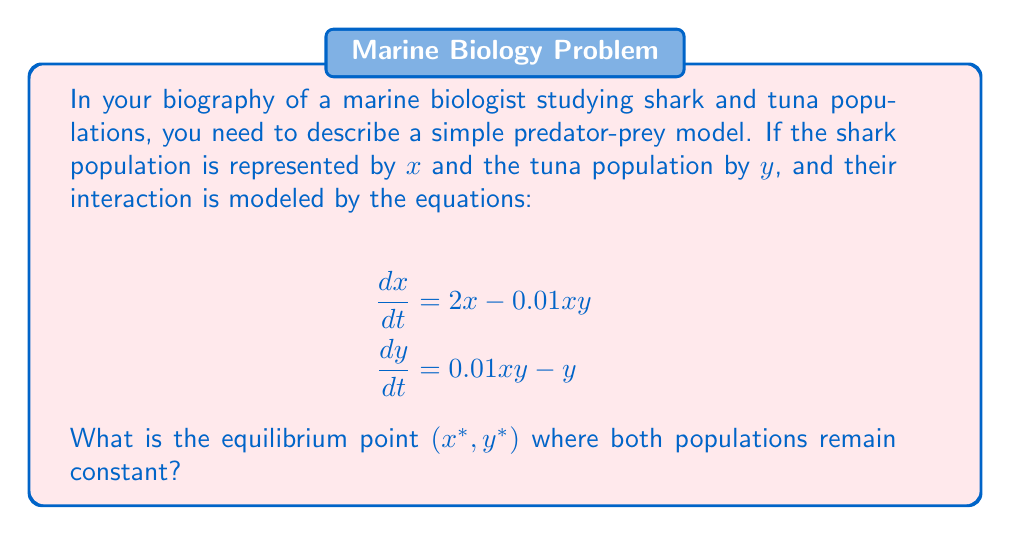Give your solution to this math problem. To find the equilibrium point, we need to set both equations equal to zero and solve for $x$ and $y$:

1. From the first equation:
   $$2x - 0.01xy = 0$$
   $$x(2 - 0.01y) = 0$$
   Either $x = 0$ or $2 - 0.01y = 0$

2. From the second equation:
   $$0.01xy - y = 0$$
   $$y(0.01x - 1) = 0$$
   Either $y = 0$ or $0.01x - 1 = 0$

3. The trivial equilibrium $(0, 0)$ is not interesting for our model, so we solve:
   $$2 - 0.01y = 0$$
   $$y = 200$$

   $$0.01x - 1 = 0$$
   $$x = 100$$

4. Therefore, the non-trivial equilibrium point is $(100, 200)$

5. We can verify this by substituting these values back into the original equations:
   $$\frac{dx}{dt} = 2(100) - 0.01(100)(200) = 200 - 200 = 0$$
   $$\frac{dy}{dt} = 0.01(100)(200) - 200 = 200 - 200 = 0$$

Both equations equal zero, confirming that $(100, 200)$ is indeed the equilibrium point.
Answer: $(100, 200)$ 